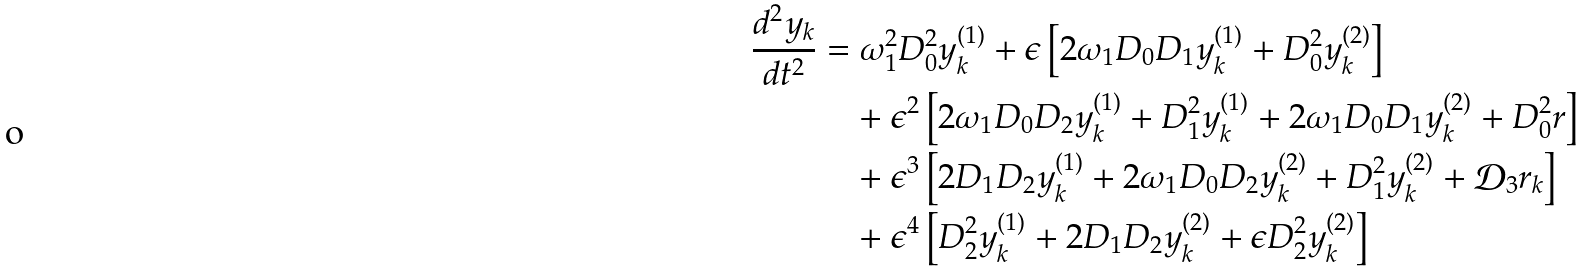Convert formula to latex. <formula><loc_0><loc_0><loc_500><loc_500>\frac { d ^ { 2 } y _ { k } } { d t ^ { 2 } } & = \omega _ { 1 } ^ { 2 } D _ { 0 } ^ { 2 } y _ { k } ^ { ( 1 ) } + \epsilon \left [ 2 \omega _ { 1 } D _ { 0 } D _ { 1 } y _ { k } ^ { ( 1 ) } + D _ { 0 } ^ { 2 } y _ { k } ^ { ( 2 ) } \right ] \\ & \quad + \epsilon ^ { 2 } \left [ 2 \omega _ { 1 } D _ { 0 } D _ { 2 } y _ { k } ^ { ( 1 ) } + D _ { 1 } ^ { 2 } y _ { k } ^ { ( 1 ) } + 2 \omega _ { 1 } D _ { 0 } D _ { 1 } y _ { k } ^ { ( 2 ) } + D _ { 0 } ^ { 2 } r \right ] \\ & \quad + \epsilon ^ { 3 } \left [ 2 D _ { 1 } D _ { 2 } y _ { k } ^ { ( 1 ) } + 2 \omega _ { 1 } D _ { 0 } D _ { 2 } y _ { k } ^ { ( 2 ) } + D _ { 1 } ^ { 2 } y _ { k } ^ { ( 2 ) } + \mathcal { D } _ { 3 } r _ { k } \right ] \\ & \quad + \epsilon ^ { 4 } \left [ D _ { 2 } ^ { 2 } y _ { k } ^ { ( 1 ) } + 2 D _ { 1 } D _ { 2 } y _ { k } ^ { ( 2 ) } + \epsilon D _ { 2 } ^ { 2 } y _ { k } ^ { ( 2 ) } \right ]</formula> 